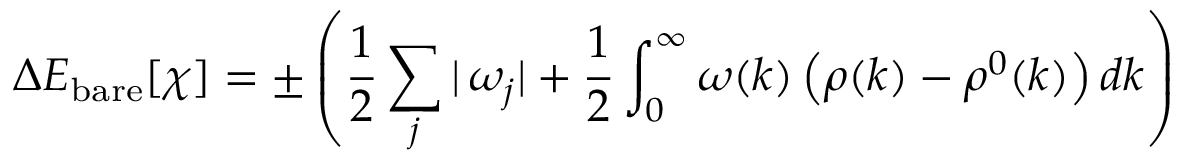Convert formula to latex. <formula><loc_0><loc_0><loc_500><loc_500>\Delta E _ { b a r e } [ \chi ] = \pm \left ( \frac { 1 } { 2 } \sum _ { j } | \, \omega _ { j } | + \frac { 1 } { 2 } \int _ { 0 } ^ { \infty } \omega ( k ) \left ( \rho ( k ) - \rho ^ { 0 } ( k ) \right ) d k \right )</formula> 